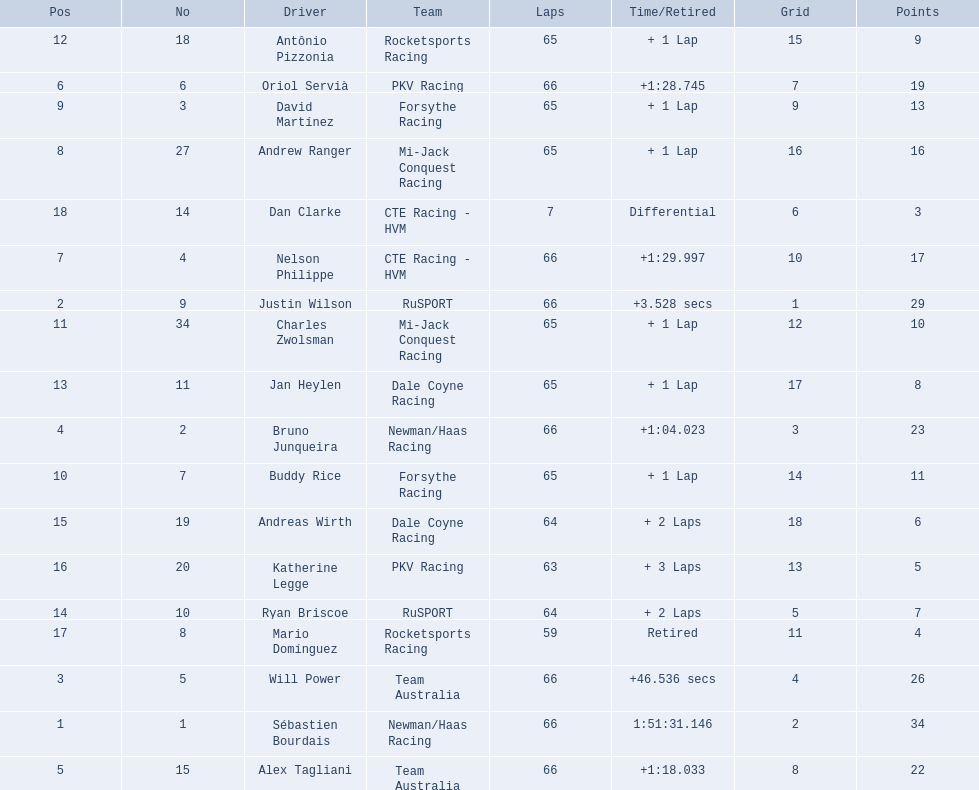What was the highest amount of points scored in the 2006 gran premio? 34. Who scored 34 points? Sébastien Bourdais. 